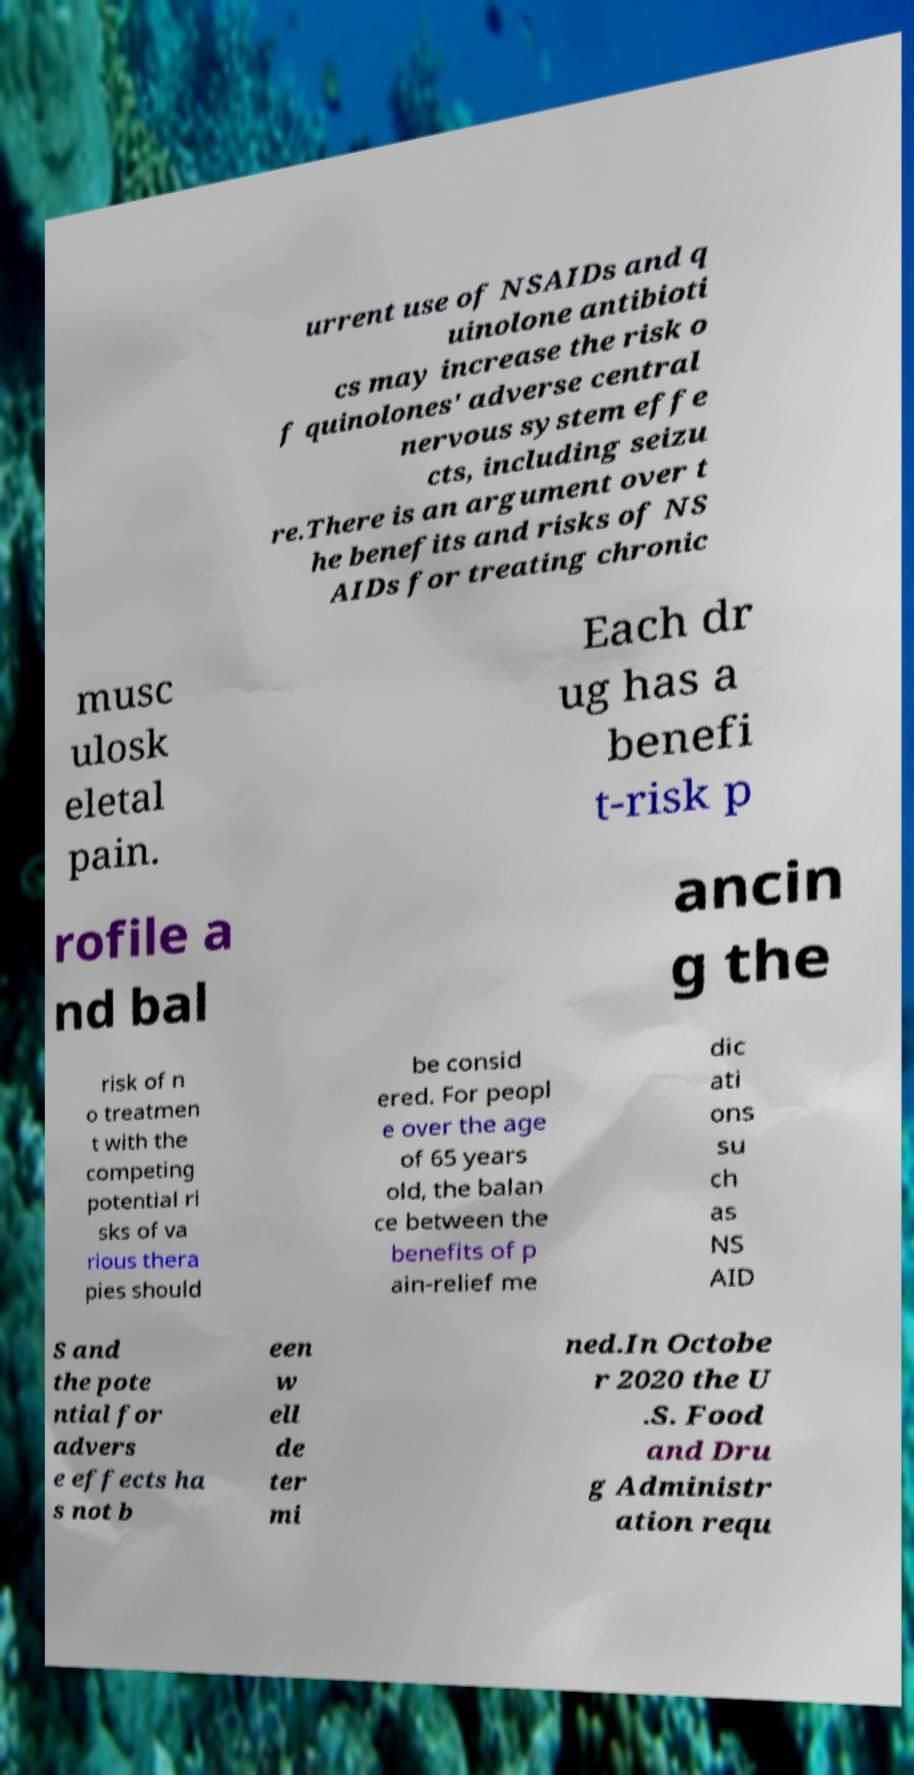For documentation purposes, I need the text within this image transcribed. Could you provide that? urrent use of NSAIDs and q uinolone antibioti cs may increase the risk o f quinolones' adverse central nervous system effe cts, including seizu re.There is an argument over t he benefits and risks of NS AIDs for treating chronic musc ulosk eletal pain. Each dr ug has a benefi t-risk p rofile a nd bal ancin g the risk of n o treatmen t with the competing potential ri sks of va rious thera pies should be consid ered. For peopl e over the age of 65 years old, the balan ce between the benefits of p ain-relief me dic ati ons su ch as NS AID S and the pote ntial for advers e effects ha s not b een w ell de ter mi ned.In Octobe r 2020 the U .S. Food and Dru g Administr ation requ 